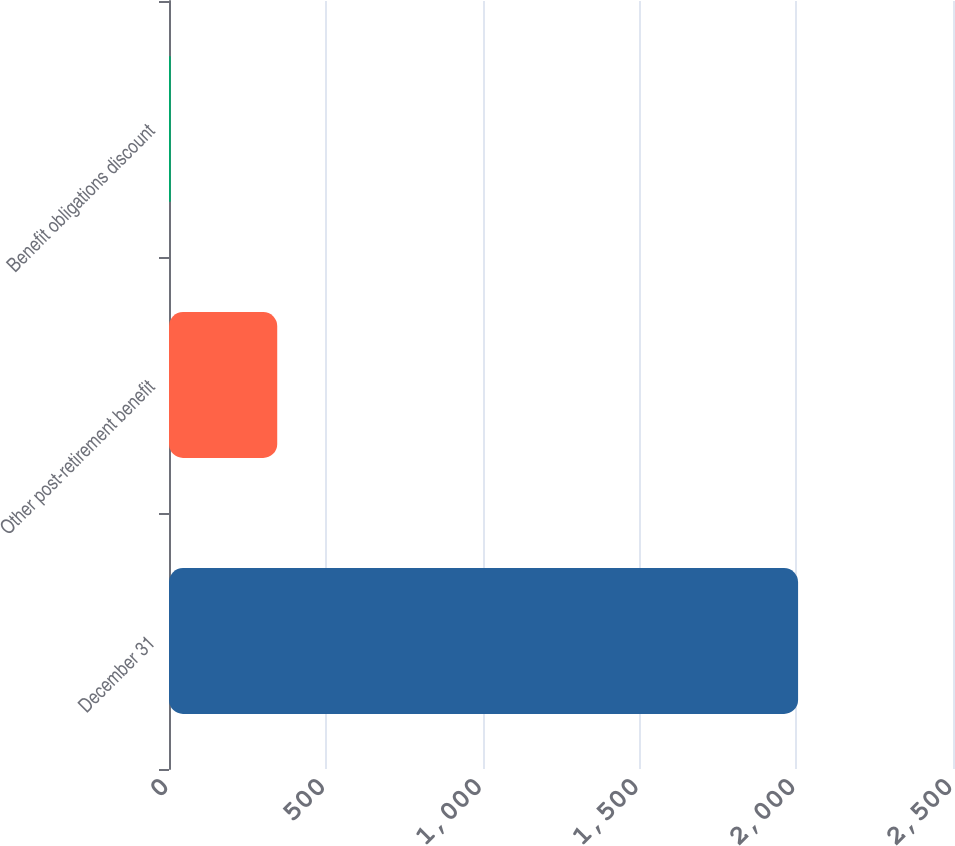Convert chart to OTSL. <chart><loc_0><loc_0><loc_500><loc_500><bar_chart><fcel>December 31<fcel>Other post-retirement benefit<fcel>Benefit obligations discount<nl><fcel>2006<fcel>345.1<fcel>5.7<nl></chart> 